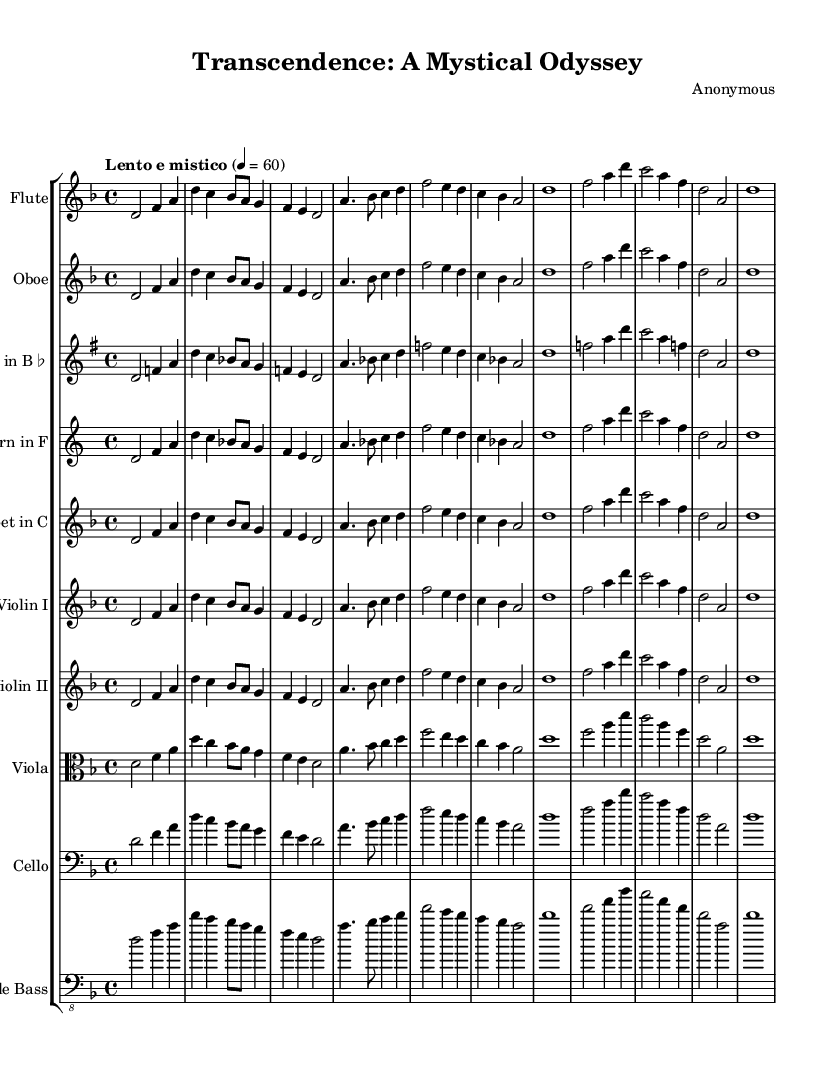What is the key signature of this music? The key signature shows two flat symbols, indicating that the music is in D minor.
Answer: D minor What is the time signature of this music? The time signature shows a 4 over 4 notation, which means there are four beats in each measure and the quarter note gets one beat.
Answer: 4/4 What is the tempo marking for this piece? The tempo is marked as "Lento e mistico," which indicates a slow and mystical pace.
Answer: Lento e mistico How many distinct themes are presented in this piece? There are three distinct themes labeled as theme A, theme B, and theme C, respectively. Each theme has its own melodic line.
Answer: 3 Which instrument is playing the highest pitch throughout the score? The flute typically plays the highest pitch in the orchestration, due to its range and placement in the score.
Answer: Flute What emotional quality does the music convey, based on the tempo and key signature? The combination of a slow tempo and the D minor key often conveys a deeply introspective or mystical quality in Romantic music, suggesting a journey into reflection or transcendence.
Answer: Mystical Which instruments play the same melodic line as theme A? The instruments playing the same melodic line for theme A are the flute, oboe, clarinet in B flat, horn in F, trumpet in C, and both violins.
Answer: Flute, Oboe, Clarinet in B flat, Horn in F, Trumpet in C, Violin I, Violin II 